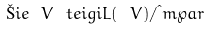Convert formula to latex. <formula><loc_0><loc_0><loc_500><loc_500>\L i e { \ V } \ t e i g i L ( \ V ) / \i m \wp a r</formula> 